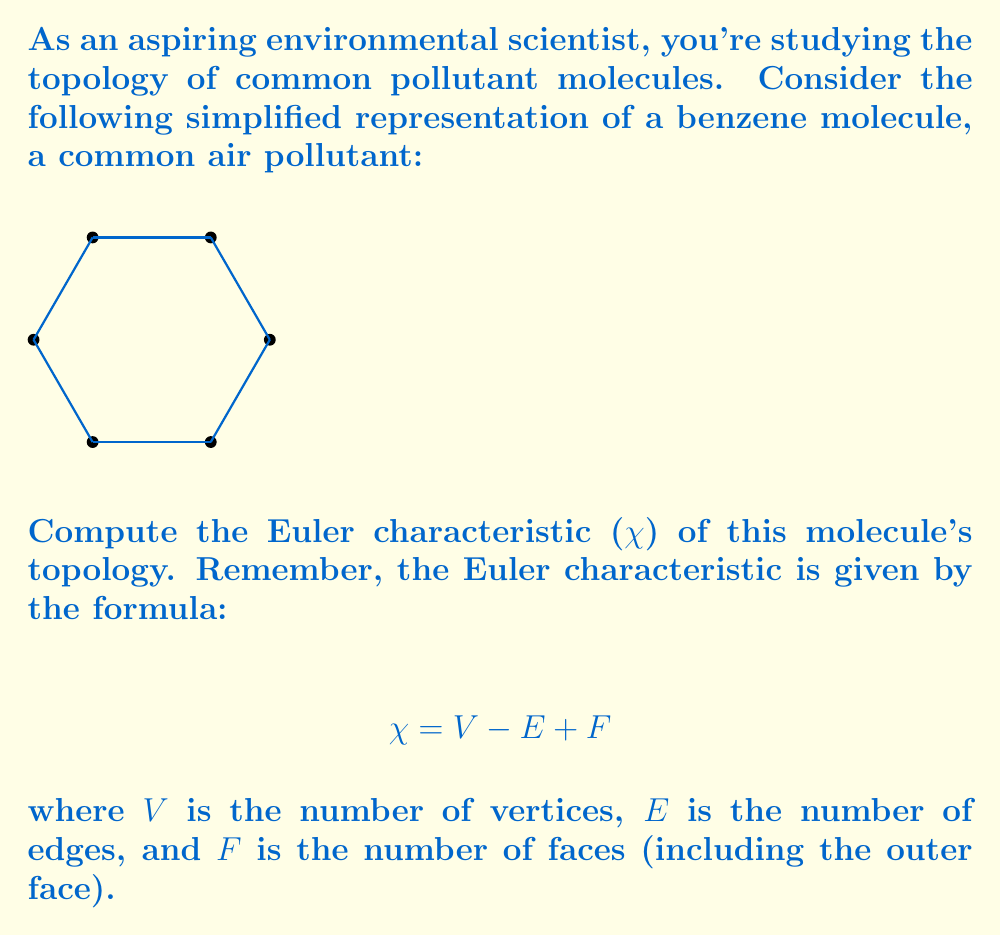Help me with this question. Let's approach this step-by-step:

1. Count the vertices (V):
   The benzene molecule has 6 vertices, representing the carbon atoms.
   V = 6

2. Count the edges (E):
   There are 6 edges connecting the vertices.
   E = 6

3. Count the faces (F):
   - There is one inner face (the hexagon)
   - There is also the outer face (the area surrounding the hexagon)
   F = 2

4. Apply the Euler characteristic formula:
   $$ \chi = V - E + F $$
   $$ \chi = 6 - 6 + 2 $$
   $$ \chi = 2 $$

The Euler characteristic of this benzene molecule topology is 2, which is consistent with the fact that it's topologically equivalent to a sphere (as it can be projected onto a plane with no crossings).

This result is important in environmental science as it helps characterize the structure and properties of pollutant molecules, which can influence their behavior in the environment and their interactions with biological systems.
Answer: $\chi = 2$ 